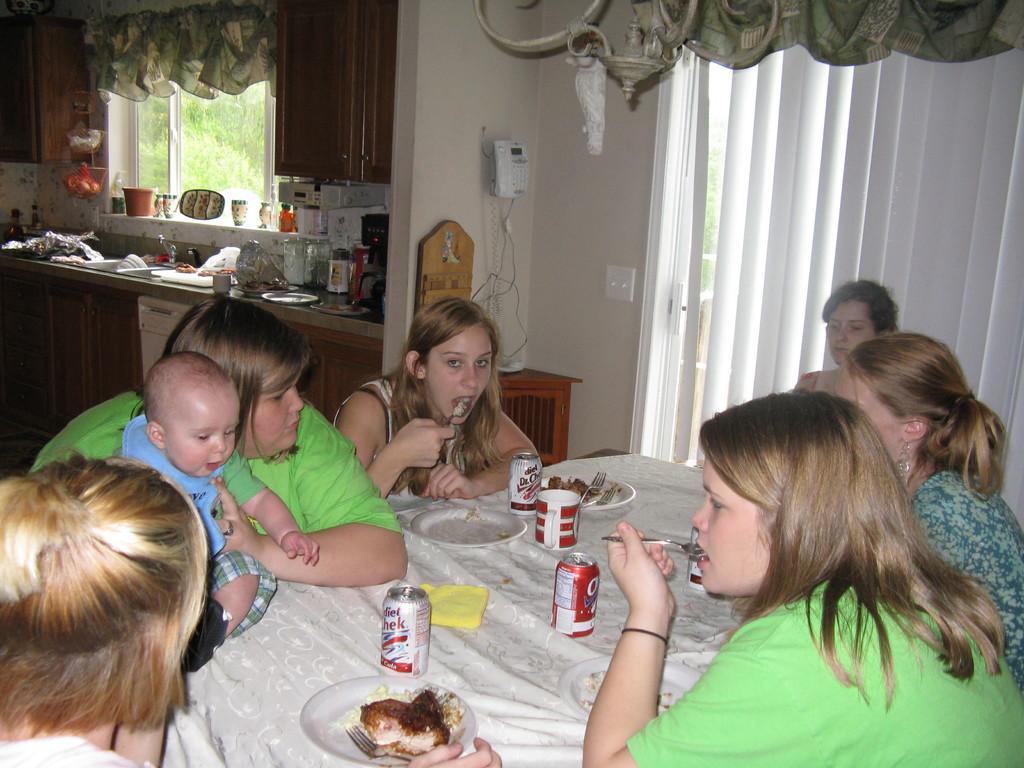Describe this image in one or two sentences. In the image there are group of women sat on chairs around the table having food and this picture clicked in the kitchen room,On right side there is window with curtain. 